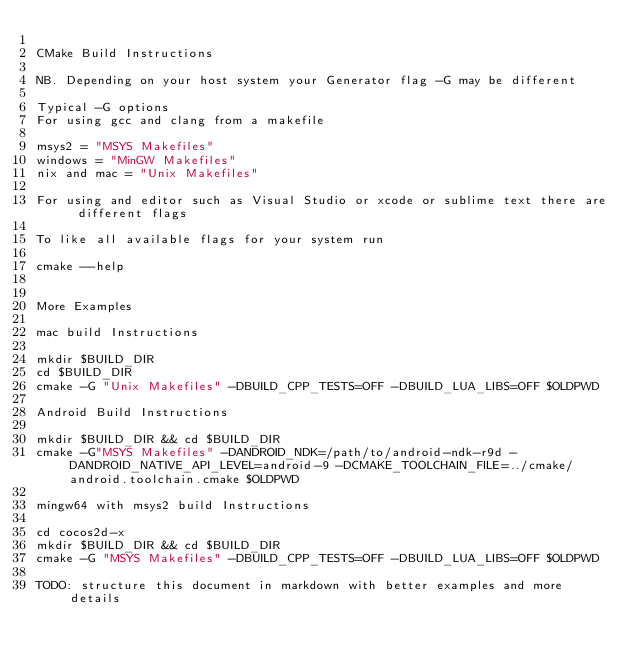<code> <loc_0><loc_0><loc_500><loc_500><_CMake_>
CMake Build Instructions

NB. Depending on your host system your Generator flag -G may be different

Typical -G options
For using gcc and clang from a makefile

msys2 = "MSYS Makefiles"
windows = "MinGW Makefiles"
nix and mac = "Unix Makefiles"

For using and editor such as Visual Studio or xcode or sublime text there are different flags

To like all available flags for your system run

cmake --help


More Examples

mac build Instructions

mkdir $BUILD_DIR
cd $BUILD_DIR
cmake -G "Unix Makefiles" -DBUILD_CPP_TESTS=OFF -DBUILD_LUA_LIBS=OFF $OLDPWD

Android Build Instructions

mkdir $BUILD_DIR && cd $BUILD_DIR
cmake -G"MSYS Makefiles" -DANDROID_NDK=/path/to/android-ndk-r9d -DANDROID_NATIVE_API_LEVEL=android-9 -DCMAKE_TOOLCHAIN_FILE=../cmake/android.toolchain.cmake $OLDPWD

mingw64 with msys2 build Instructions

cd cocos2d-x
mkdir $BUILD_DIR && cd $BUILD_DIR
cmake -G "MSYS Makefiles" -DBUILD_CPP_TESTS=OFF -DBUILD_LUA_LIBS=OFF $OLDPWD

TODO: structure this document in markdown with better examples and more details
</code> 